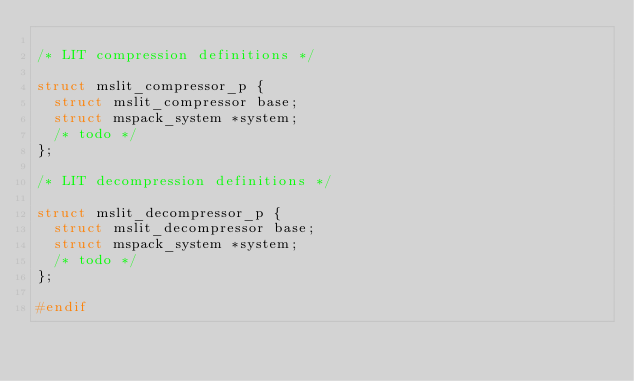Convert code to text. <code><loc_0><loc_0><loc_500><loc_500><_C_>
/* LIT compression definitions */

struct mslit_compressor_p {
  struct mslit_compressor base;
  struct mspack_system *system;
  /* todo */
};

/* LIT decompression definitions */

struct mslit_decompressor_p {
  struct mslit_decompressor base;
  struct mspack_system *system;
  /* todo */
};

#endif
</code> 